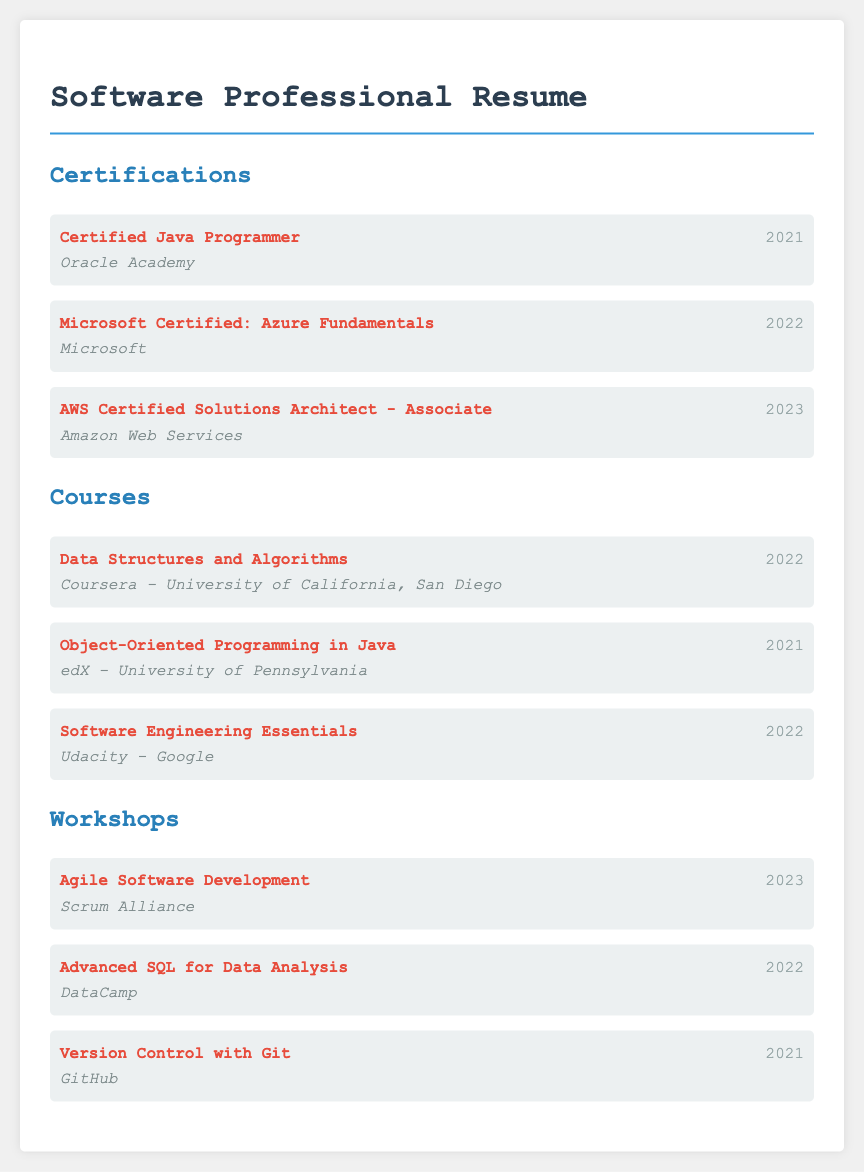what certification was obtained from Oracle Academy? The document lists the certification from Oracle Academy as "Certified Java Programmer."
Answer: Certified Java Programmer which year was the Microsoft Certified: Azure Fundamentals acquired? The document states that the Microsoft Certified: Azure Fundamentals was obtained in 2022.
Answer: 2022 who provided the workshop on Version Control with Git? The workshop on Version Control with Git was provided by GitHub.
Answer: GitHub what course was attended in 2022 related to data structures? The course related to data structures attended in 2022 was "Data Structures and Algorithms."
Answer: Data Structures and Algorithms how many certifications are listed in the document? The document includes three certifications, totaling to three listed items.
Answer: 3 which organization conducted the Agile Software Development workshop? The Agile Software Development workshop was conducted by Scrum Alliance.
Answer: Scrum Alliance what is the title of the 2021 course on object-oriented programming? The title of the 2021 course on object-oriented programming is "Object-Oriented Programming in Java."
Answer: Object-Oriented Programming in Java which certification was acquired last? The last certification obtained, as per the document, is "AWS Certified Solutions Architect - Associate."
Answer: AWS Certified Solutions Architect - Associate how many workshops focused on SQL are mentioned? The document mentions one workshop that focused on SQL, which is "Advanced SQL for Data Analysis."
Answer: 1 